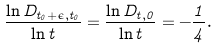<formula> <loc_0><loc_0><loc_500><loc_500>\frac { \ln D _ { t _ { 0 } + \epsilon , t _ { 0 } } } { \ln t } = \frac { \ln D _ { t , 0 } } { \ln t } = - \frac { 1 } { 4 } .</formula> 